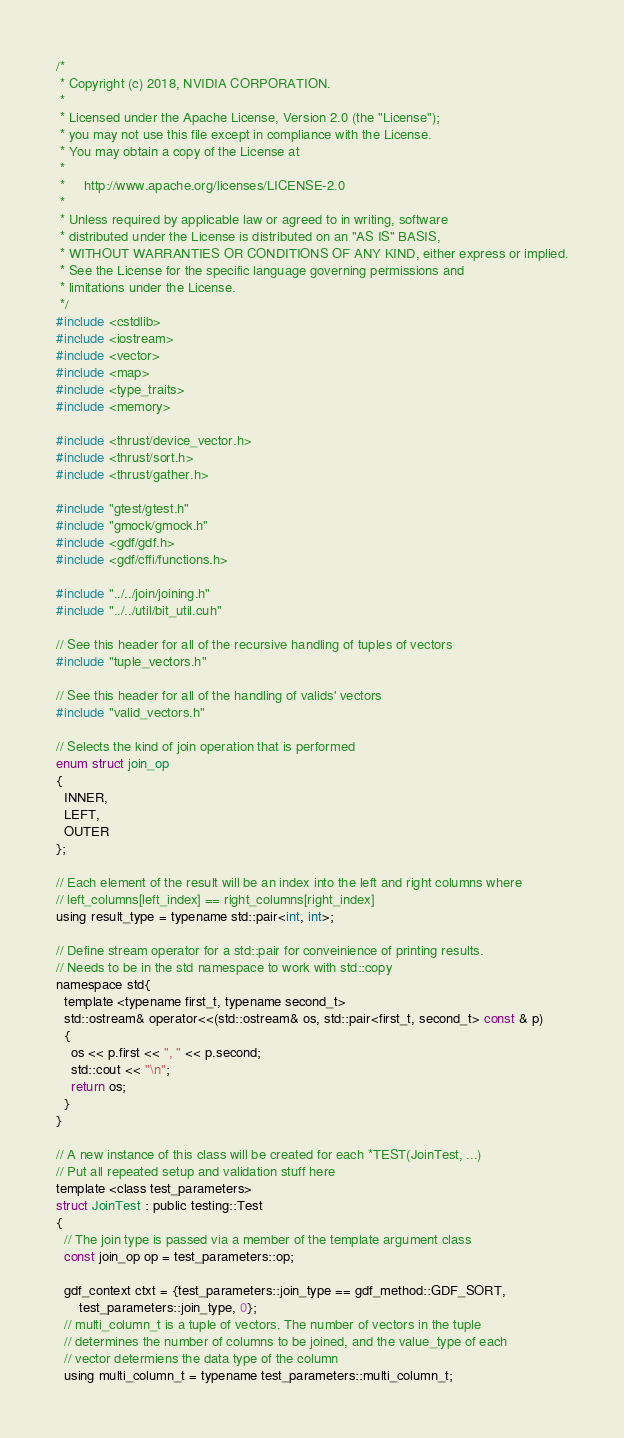Convert code to text. <code><loc_0><loc_0><loc_500><loc_500><_Cuda_>/*
 * Copyright (c) 2018, NVIDIA CORPORATION.
 *
 * Licensed under the Apache License, Version 2.0 (the "License");
 * you may not use this file except in compliance with the License.
 * You may obtain a copy of the License at
 *
 *     http://www.apache.org/licenses/LICENSE-2.0
 *
 * Unless required by applicable law or agreed to in writing, software
 * distributed under the License is distributed on an "AS IS" BASIS,
 * WITHOUT WARRANTIES OR CONDITIONS OF ANY KIND, either express or implied.
 * See the License for the specific language governing permissions and
 * limitations under the License.
 */
#include <cstdlib>
#include <iostream>
#include <vector>
#include <map>
#include <type_traits>
#include <memory>

#include <thrust/device_vector.h>
#include <thrust/sort.h>
#include <thrust/gather.h>

#include "gtest/gtest.h"
#include "gmock/gmock.h"
#include <gdf/gdf.h>
#include <gdf/cffi/functions.h>

#include "../../join/joining.h"
#include "../../util/bit_util.cuh"

// See this header for all of the recursive handling of tuples of vectors
#include "tuple_vectors.h"

// See this header for all of the handling of valids' vectors 
#include "valid_vectors.h"

// Selects the kind of join operation that is performed
enum struct join_op
{
  INNER,
  LEFT,
  OUTER
};

// Each element of the result will be an index into the left and right columns where
// left_columns[left_index] == right_columns[right_index]
using result_type = typename std::pair<int, int>;

// Define stream operator for a std::pair for conveinience of printing results.
// Needs to be in the std namespace to work with std::copy
namespace std{
  template <typename first_t, typename second_t>
  std::ostream& operator<<(std::ostream& os, std::pair<first_t, second_t> const & p)
  {
    os << p.first << ", " << p.second;
    std::cout << "\n";
    return os;
  }
}

// A new instance of this class will be created for each *TEST(JoinTest, ...)
// Put all repeated setup and validation stuff here
template <class test_parameters>
struct JoinTest : public testing::Test
{
  // The join type is passed via a member of the template argument class
  const join_op op = test_parameters::op;

  gdf_context ctxt = {test_parameters::join_type == gdf_method::GDF_SORT,
      test_parameters::join_type, 0};
  // multi_column_t is a tuple of vectors. The number of vectors in the tuple
  // determines the number of columns to be joined, and the value_type of each
  // vector determiens the data type of the column
  using multi_column_t = typename test_parameters::multi_column_t;</code> 